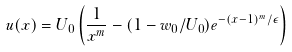<formula> <loc_0><loc_0><loc_500><loc_500>u ( x ) = U _ { 0 } \left ( \frac { 1 } { x ^ { m } } - ( 1 - w _ { 0 } / U _ { 0 } ) e ^ { - ( x - 1 ) ^ { m } / \epsilon } \right )</formula> 